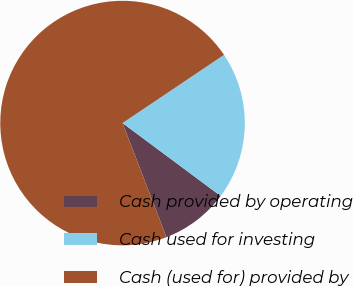Convert chart to OTSL. <chart><loc_0><loc_0><loc_500><loc_500><pie_chart><fcel>Cash provided by operating<fcel>Cash used for investing<fcel>Cash (used for) provided by<nl><fcel>8.98%<fcel>19.59%<fcel>71.43%<nl></chart> 